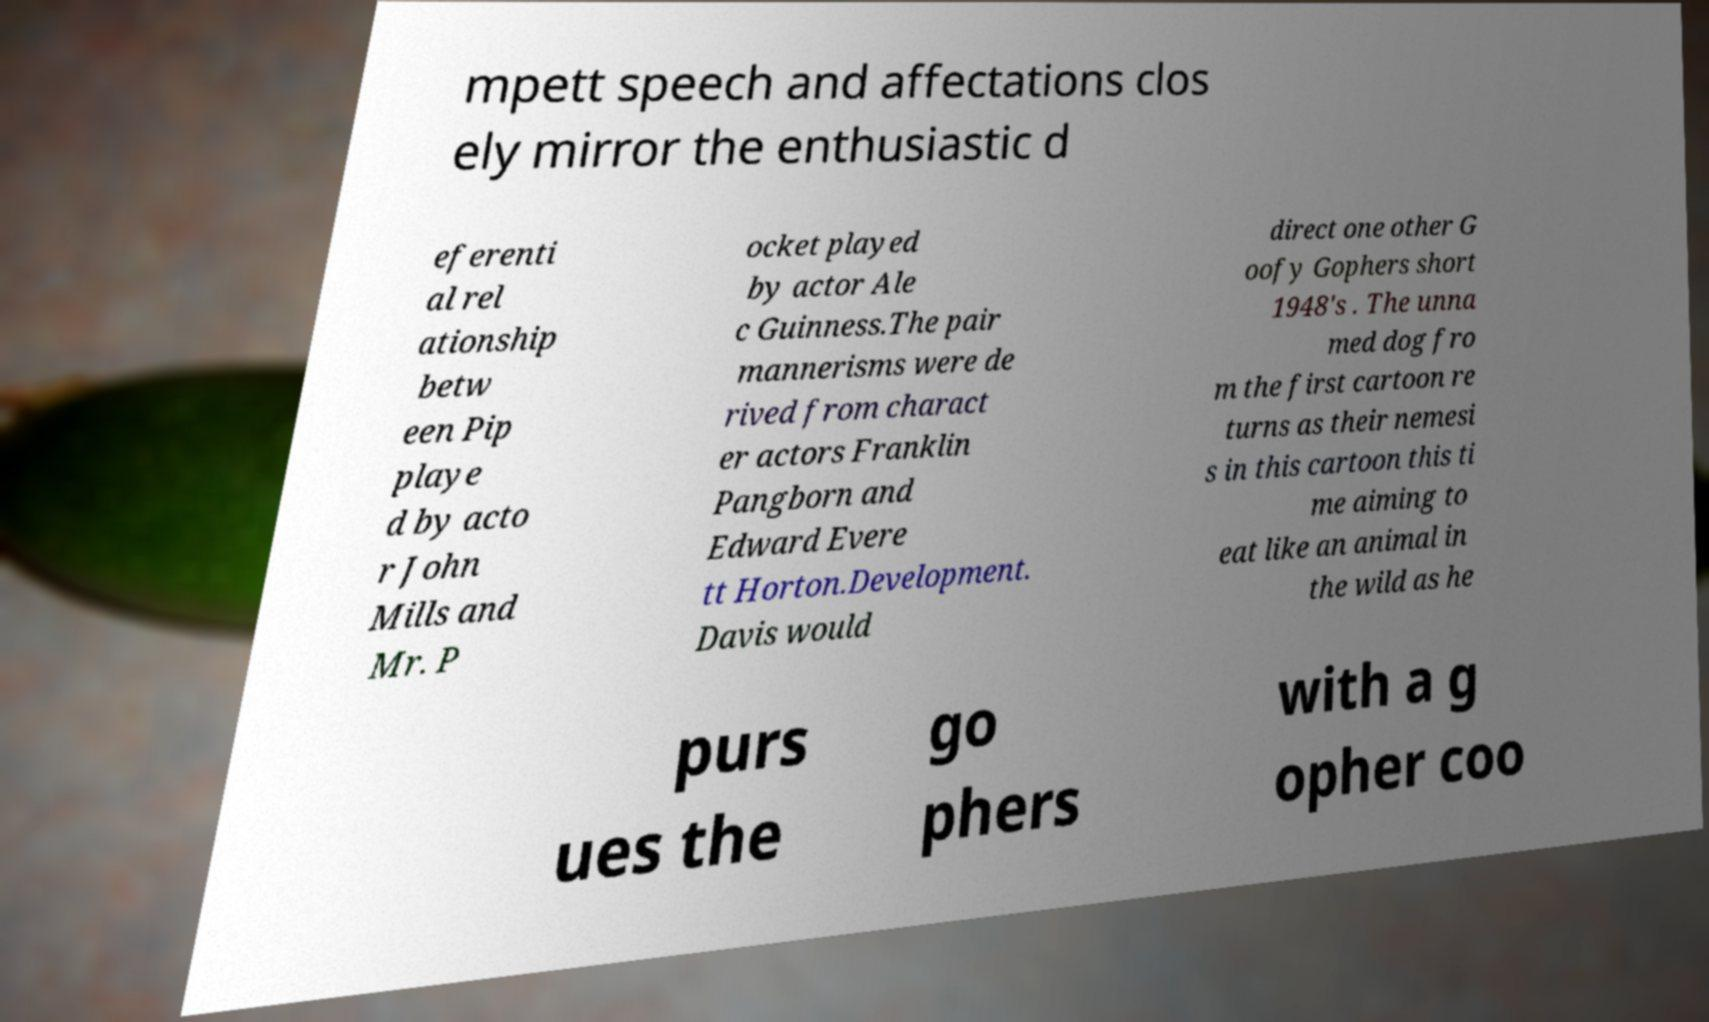I need the written content from this picture converted into text. Can you do that? mpett speech and affectations clos ely mirror the enthusiastic d eferenti al rel ationship betw een Pip playe d by acto r John Mills and Mr. P ocket played by actor Ale c Guinness.The pair mannerisms were de rived from charact er actors Franklin Pangborn and Edward Evere tt Horton.Development. Davis would direct one other G oofy Gophers short 1948's . The unna med dog fro m the first cartoon re turns as their nemesi s in this cartoon this ti me aiming to eat like an animal in the wild as he purs ues the go phers with a g opher coo 